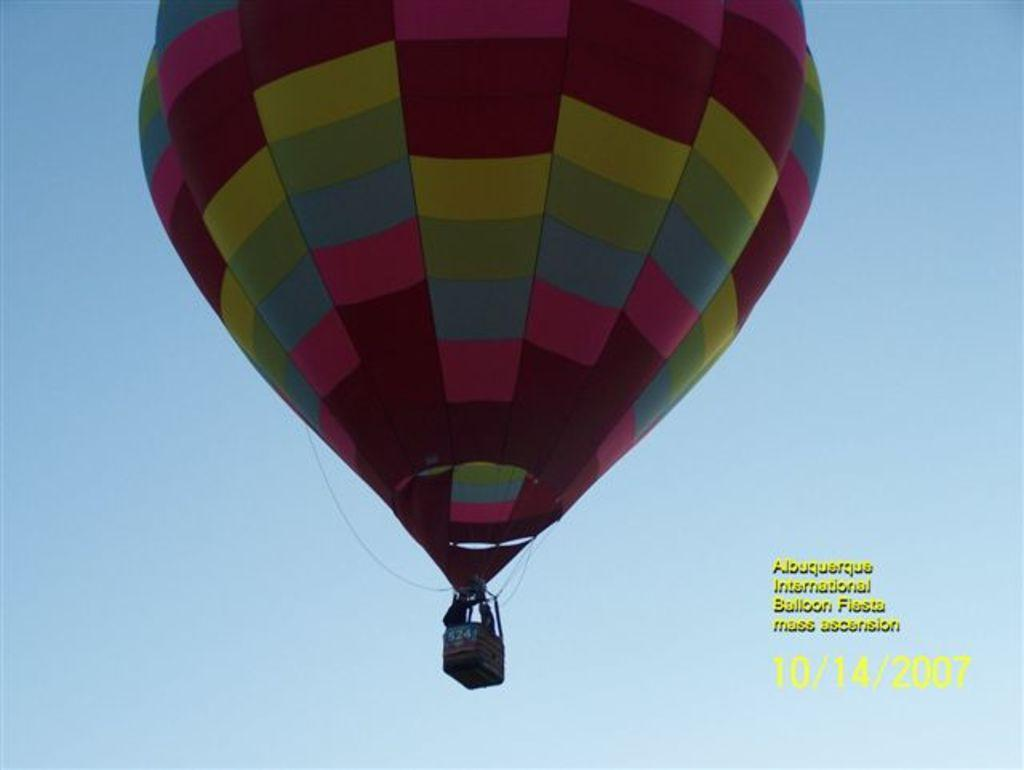What is the main subject in the image? There is an air balloon in the image. Where is the air balloon located in the image? The air balloon is in the front of the image. What can be seen in the background of the image? The sky is visible in the background of the image. Are there any additional features on the image? Yes, there are watermarks on the bottom right side of the image. What type of health advice is being given in the image? There is no health advice present in the image; it features an air balloon in the front with a visible sky in the background and watermarks on the bottom right side. 